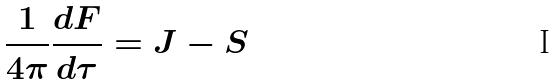<formula> <loc_0><loc_0><loc_500><loc_500>\frac { 1 } { 4 \pi } \frac { d F } { d \tau } = J - S</formula> 